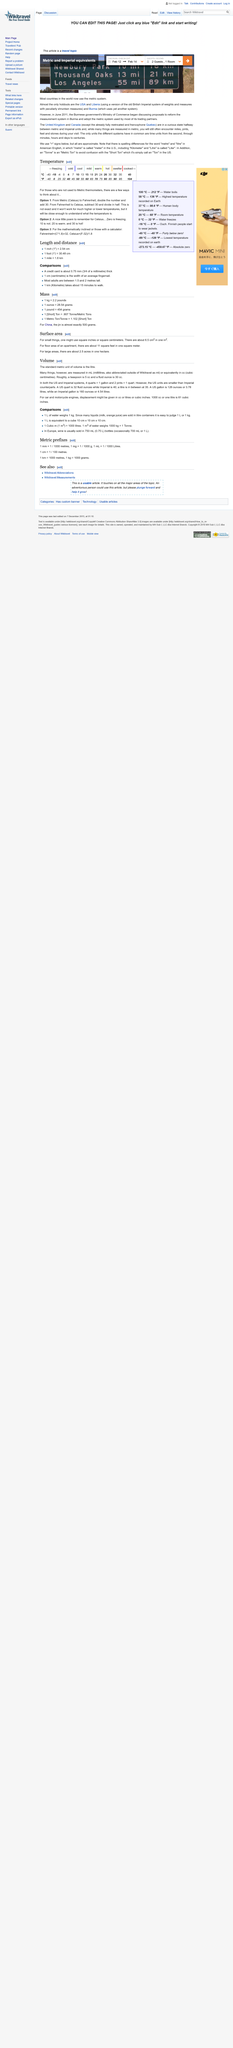Mention a couple of crucial points in this snapshot. The US gallon is smaller in volume than the Imperial gallon. It is a fact that a US quart is equal to 32 fluid ounces. The standard metric unit of volume is the litre, as declared. 